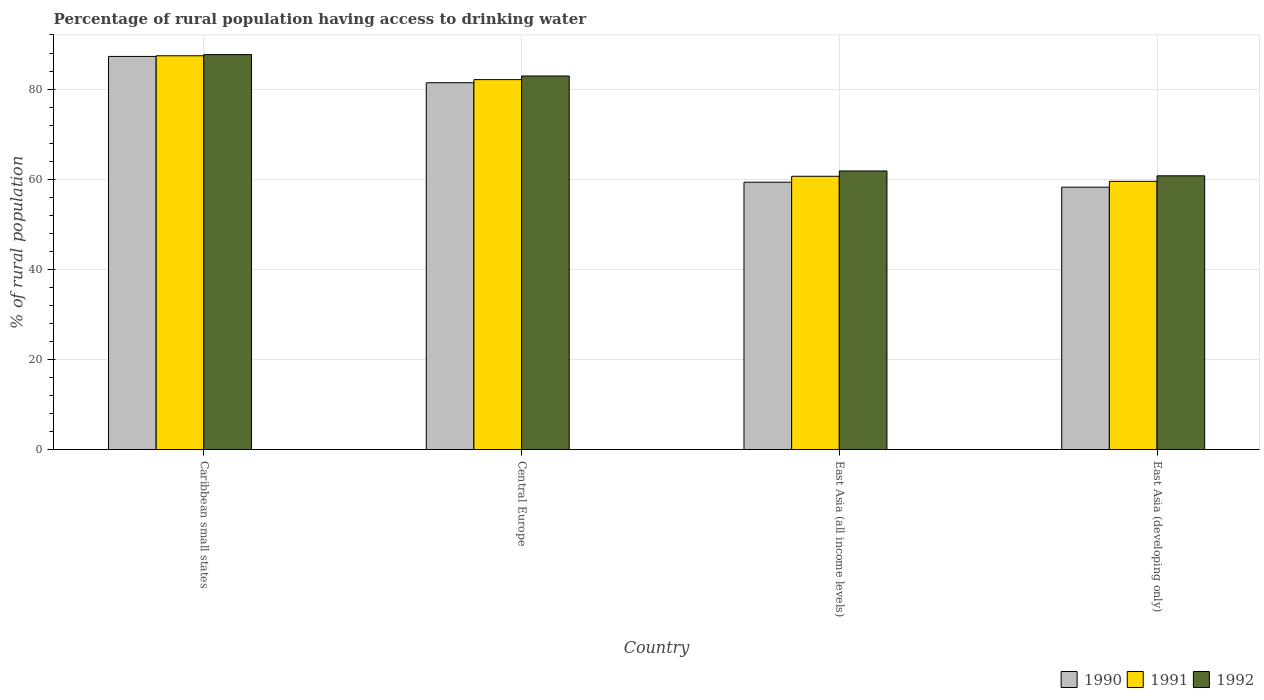Are the number of bars on each tick of the X-axis equal?
Your answer should be very brief. Yes. How many bars are there on the 2nd tick from the left?
Your answer should be very brief. 3. What is the label of the 2nd group of bars from the left?
Offer a terse response. Central Europe. What is the percentage of rural population having access to drinking water in 1991 in Caribbean small states?
Keep it short and to the point. 87.39. Across all countries, what is the maximum percentage of rural population having access to drinking water in 1992?
Offer a very short reply. 87.64. Across all countries, what is the minimum percentage of rural population having access to drinking water in 1990?
Your answer should be compact. 58.23. In which country was the percentage of rural population having access to drinking water in 1991 maximum?
Give a very brief answer. Caribbean small states. In which country was the percentage of rural population having access to drinking water in 1992 minimum?
Your answer should be compact. East Asia (developing only). What is the total percentage of rural population having access to drinking water in 1991 in the graph?
Your answer should be compact. 289.65. What is the difference between the percentage of rural population having access to drinking water in 1991 in Caribbean small states and that in East Asia (all income levels)?
Provide a short and direct response. 26.74. What is the difference between the percentage of rural population having access to drinking water in 1990 in Central Europe and the percentage of rural population having access to drinking water in 1991 in East Asia (all income levels)?
Your answer should be very brief. 20.76. What is the average percentage of rural population having access to drinking water in 1990 per country?
Give a very brief answer. 71.55. What is the difference between the percentage of rural population having access to drinking water of/in 1991 and percentage of rural population having access to drinking water of/in 1992 in East Asia (developing only)?
Your answer should be very brief. -1.23. What is the ratio of the percentage of rural population having access to drinking water in 1991 in Central Europe to that in East Asia (all income levels)?
Make the answer very short. 1.35. What is the difference between the highest and the second highest percentage of rural population having access to drinking water in 1992?
Offer a very short reply. 21.08. What is the difference between the highest and the lowest percentage of rural population having access to drinking water in 1992?
Provide a succinct answer. 26.9. In how many countries, is the percentage of rural population having access to drinking water in 1990 greater than the average percentage of rural population having access to drinking water in 1990 taken over all countries?
Offer a terse response. 2. Is the sum of the percentage of rural population having access to drinking water in 1992 in Central Europe and East Asia (all income levels) greater than the maximum percentage of rural population having access to drinking water in 1990 across all countries?
Ensure brevity in your answer.  Yes. What does the 3rd bar from the left in Central Europe represents?
Your response must be concise. 1992. Is it the case that in every country, the sum of the percentage of rural population having access to drinking water in 1992 and percentage of rural population having access to drinking water in 1991 is greater than the percentage of rural population having access to drinking water in 1990?
Offer a very short reply. Yes. How many bars are there?
Ensure brevity in your answer.  12. How many countries are there in the graph?
Provide a succinct answer. 4. What is the difference between two consecutive major ticks on the Y-axis?
Your response must be concise. 20. Does the graph contain any zero values?
Provide a succinct answer. No. Where does the legend appear in the graph?
Offer a terse response. Bottom right. What is the title of the graph?
Make the answer very short. Percentage of rural population having access to drinking water. Does "1996" appear as one of the legend labels in the graph?
Your answer should be compact. No. What is the label or title of the X-axis?
Your answer should be compact. Country. What is the label or title of the Y-axis?
Ensure brevity in your answer.  % of rural population. What is the % of rural population of 1990 in Caribbean small states?
Offer a terse response. 87.24. What is the % of rural population of 1991 in Caribbean small states?
Offer a very short reply. 87.39. What is the % of rural population of 1992 in Caribbean small states?
Ensure brevity in your answer.  87.64. What is the % of rural population of 1990 in Central Europe?
Your response must be concise. 81.4. What is the % of rural population in 1991 in Central Europe?
Provide a succinct answer. 82.1. What is the % of rural population of 1992 in Central Europe?
Your response must be concise. 82.9. What is the % of rural population of 1990 in East Asia (all income levels)?
Keep it short and to the point. 59.33. What is the % of rural population in 1991 in East Asia (all income levels)?
Your response must be concise. 60.64. What is the % of rural population in 1992 in East Asia (all income levels)?
Your answer should be compact. 61.82. What is the % of rural population in 1990 in East Asia (developing only)?
Provide a short and direct response. 58.23. What is the % of rural population in 1991 in East Asia (developing only)?
Your response must be concise. 59.52. What is the % of rural population in 1992 in East Asia (developing only)?
Provide a succinct answer. 60.75. Across all countries, what is the maximum % of rural population of 1990?
Provide a succinct answer. 87.24. Across all countries, what is the maximum % of rural population of 1991?
Your answer should be compact. 87.39. Across all countries, what is the maximum % of rural population in 1992?
Ensure brevity in your answer.  87.64. Across all countries, what is the minimum % of rural population of 1990?
Give a very brief answer. 58.23. Across all countries, what is the minimum % of rural population of 1991?
Make the answer very short. 59.52. Across all countries, what is the minimum % of rural population in 1992?
Offer a terse response. 60.75. What is the total % of rural population in 1990 in the graph?
Give a very brief answer. 286.2. What is the total % of rural population of 1991 in the graph?
Provide a short and direct response. 289.65. What is the total % of rural population in 1992 in the graph?
Your answer should be compact. 293.11. What is the difference between the % of rural population of 1990 in Caribbean small states and that in Central Europe?
Provide a short and direct response. 5.84. What is the difference between the % of rural population in 1991 in Caribbean small states and that in Central Europe?
Offer a very short reply. 5.29. What is the difference between the % of rural population of 1992 in Caribbean small states and that in Central Europe?
Make the answer very short. 4.74. What is the difference between the % of rural population of 1990 in Caribbean small states and that in East Asia (all income levels)?
Ensure brevity in your answer.  27.91. What is the difference between the % of rural population of 1991 in Caribbean small states and that in East Asia (all income levels)?
Keep it short and to the point. 26.74. What is the difference between the % of rural population in 1992 in Caribbean small states and that in East Asia (all income levels)?
Keep it short and to the point. 25.82. What is the difference between the % of rural population in 1990 in Caribbean small states and that in East Asia (developing only)?
Make the answer very short. 29.01. What is the difference between the % of rural population of 1991 in Caribbean small states and that in East Asia (developing only)?
Your answer should be very brief. 27.87. What is the difference between the % of rural population of 1992 in Caribbean small states and that in East Asia (developing only)?
Offer a terse response. 26.9. What is the difference between the % of rural population in 1990 in Central Europe and that in East Asia (all income levels)?
Offer a terse response. 22.07. What is the difference between the % of rural population of 1991 in Central Europe and that in East Asia (all income levels)?
Provide a succinct answer. 21.45. What is the difference between the % of rural population of 1992 in Central Europe and that in East Asia (all income levels)?
Your response must be concise. 21.08. What is the difference between the % of rural population of 1990 in Central Europe and that in East Asia (developing only)?
Give a very brief answer. 23.18. What is the difference between the % of rural population in 1991 in Central Europe and that in East Asia (developing only)?
Offer a very short reply. 22.58. What is the difference between the % of rural population in 1992 in Central Europe and that in East Asia (developing only)?
Offer a terse response. 22.16. What is the difference between the % of rural population of 1990 in East Asia (all income levels) and that in East Asia (developing only)?
Your response must be concise. 1.1. What is the difference between the % of rural population of 1991 in East Asia (all income levels) and that in East Asia (developing only)?
Offer a terse response. 1.12. What is the difference between the % of rural population in 1992 in East Asia (all income levels) and that in East Asia (developing only)?
Your answer should be very brief. 1.07. What is the difference between the % of rural population of 1990 in Caribbean small states and the % of rural population of 1991 in Central Europe?
Ensure brevity in your answer.  5.14. What is the difference between the % of rural population in 1990 in Caribbean small states and the % of rural population in 1992 in Central Europe?
Provide a succinct answer. 4.34. What is the difference between the % of rural population in 1991 in Caribbean small states and the % of rural population in 1992 in Central Europe?
Provide a succinct answer. 4.49. What is the difference between the % of rural population of 1990 in Caribbean small states and the % of rural population of 1991 in East Asia (all income levels)?
Give a very brief answer. 26.6. What is the difference between the % of rural population of 1990 in Caribbean small states and the % of rural population of 1992 in East Asia (all income levels)?
Ensure brevity in your answer.  25.42. What is the difference between the % of rural population in 1991 in Caribbean small states and the % of rural population in 1992 in East Asia (all income levels)?
Your answer should be very brief. 25.57. What is the difference between the % of rural population of 1990 in Caribbean small states and the % of rural population of 1991 in East Asia (developing only)?
Offer a very short reply. 27.72. What is the difference between the % of rural population of 1990 in Caribbean small states and the % of rural population of 1992 in East Asia (developing only)?
Provide a succinct answer. 26.5. What is the difference between the % of rural population of 1991 in Caribbean small states and the % of rural population of 1992 in East Asia (developing only)?
Make the answer very short. 26.64. What is the difference between the % of rural population of 1990 in Central Europe and the % of rural population of 1991 in East Asia (all income levels)?
Your response must be concise. 20.76. What is the difference between the % of rural population in 1990 in Central Europe and the % of rural population in 1992 in East Asia (all income levels)?
Your response must be concise. 19.58. What is the difference between the % of rural population in 1991 in Central Europe and the % of rural population in 1992 in East Asia (all income levels)?
Offer a very short reply. 20.28. What is the difference between the % of rural population in 1990 in Central Europe and the % of rural population in 1991 in East Asia (developing only)?
Your response must be concise. 21.88. What is the difference between the % of rural population of 1990 in Central Europe and the % of rural population of 1992 in East Asia (developing only)?
Keep it short and to the point. 20.66. What is the difference between the % of rural population in 1991 in Central Europe and the % of rural population in 1992 in East Asia (developing only)?
Keep it short and to the point. 21.35. What is the difference between the % of rural population in 1990 in East Asia (all income levels) and the % of rural population in 1991 in East Asia (developing only)?
Ensure brevity in your answer.  -0.19. What is the difference between the % of rural population of 1990 in East Asia (all income levels) and the % of rural population of 1992 in East Asia (developing only)?
Offer a terse response. -1.42. What is the difference between the % of rural population in 1991 in East Asia (all income levels) and the % of rural population in 1992 in East Asia (developing only)?
Your answer should be very brief. -0.1. What is the average % of rural population of 1990 per country?
Provide a short and direct response. 71.55. What is the average % of rural population in 1991 per country?
Offer a terse response. 72.41. What is the average % of rural population in 1992 per country?
Your answer should be compact. 73.28. What is the difference between the % of rural population in 1990 and % of rural population in 1991 in Caribbean small states?
Give a very brief answer. -0.15. What is the difference between the % of rural population of 1990 and % of rural population of 1992 in Caribbean small states?
Your response must be concise. -0.4. What is the difference between the % of rural population of 1991 and % of rural population of 1992 in Caribbean small states?
Offer a very short reply. -0.26. What is the difference between the % of rural population in 1990 and % of rural population in 1991 in Central Europe?
Your answer should be very brief. -0.69. What is the difference between the % of rural population of 1990 and % of rural population of 1992 in Central Europe?
Your answer should be compact. -1.5. What is the difference between the % of rural population in 1991 and % of rural population in 1992 in Central Europe?
Provide a short and direct response. -0.8. What is the difference between the % of rural population of 1990 and % of rural population of 1991 in East Asia (all income levels)?
Offer a very short reply. -1.32. What is the difference between the % of rural population of 1990 and % of rural population of 1992 in East Asia (all income levels)?
Keep it short and to the point. -2.49. What is the difference between the % of rural population of 1991 and % of rural population of 1992 in East Asia (all income levels)?
Your answer should be compact. -1.18. What is the difference between the % of rural population of 1990 and % of rural population of 1991 in East Asia (developing only)?
Keep it short and to the point. -1.29. What is the difference between the % of rural population of 1990 and % of rural population of 1992 in East Asia (developing only)?
Offer a terse response. -2.52. What is the difference between the % of rural population of 1991 and % of rural population of 1992 in East Asia (developing only)?
Your answer should be very brief. -1.23. What is the ratio of the % of rural population of 1990 in Caribbean small states to that in Central Europe?
Give a very brief answer. 1.07. What is the ratio of the % of rural population of 1991 in Caribbean small states to that in Central Europe?
Ensure brevity in your answer.  1.06. What is the ratio of the % of rural population in 1992 in Caribbean small states to that in Central Europe?
Ensure brevity in your answer.  1.06. What is the ratio of the % of rural population of 1990 in Caribbean small states to that in East Asia (all income levels)?
Offer a very short reply. 1.47. What is the ratio of the % of rural population in 1991 in Caribbean small states to that in East Asia (all income levels)?
Provide a short and direct response. 1.44. What is the ratio of the % of rural population of 1992 in Caribbean small states to that in East Asia (all income levels)?
Your response must be concise. 1.42. What is the ratio of the % of rural population of 1990 in Caribbean small states to that in East Asia (developing only)?
Ensure brevity in your answer.  1.5. What is the ratio of the % of rural population in 1991 in Caribbean small states to that in East Asia (developing only)?
Offer a very short reply. 1.47. What is the ratio of the % of rural population of 1992 in Caribbean small states to that in East Asia (developing only)?
Offer a very short reply. 1.44. What is the ratio of the % of rural population in 1990 in Central Europe to that in East Asia (all income levels)?
Make the answer very short. 1.37. What is the ratio of the % of rural population in 1991 in Central Europe to that in East Asia (all income levels)?
Give a very brief answer. 1.35. What is the ratio of the % of rural population of 1992 in Central Europe to that in East Asia (all income levels)?
Give a very brief answer. 1.34. What is the ratio of the % of rural population of 1990 in Central Europe to that in East Asia (developing only)?
Provide a short and direct response. 1.4. What is the ratio of the % of rural population of 1991 in Central Europe to that in East Asia (developing only)?
Your response must be concise. 1.38. What is the ratio of the % of rural population of 1992 in Central Europe to that in East Asia (developing only)?
Your answer should be compact. 1.36. What is the ratio of the % of rural population of 1990 in East Asia (all income levels) to that in East Asia (developing only)?
Ensure brevity in your answer.  1.02. What is the ratio of the % of rural population in 1991 in East Asia (all income levels) to that in East Asia (developing only)?
Provide a succinct answer. 1.02. What is the ratio of the % of rural population in 1992 in East Asia (all income levels) to that in East Asia (developing only)?
Provide a short and direct response. 1.02. What is the difference between the highest and the second highest % of rural population in 1990?
Provide a short and direct response. 5.84. What is the difference between the highest and the second highest % of rural population of 1991?
Provide a short and direct response. 5.29. What is the difference between the highest and the second highest % of rural population in 1992?
Offer a very short reply. 4.74. What is the difference between the highest and the lowest % of rural population in 1990?
Your response must be concise. 29.01. What is the difference between the highest and the lowest % of rural population of 1991?
Your answer should be very brief. 27.87. What is the difference between the highest and the lowest % of rural population of 1992?
Your answer should be compact. 26.9. 